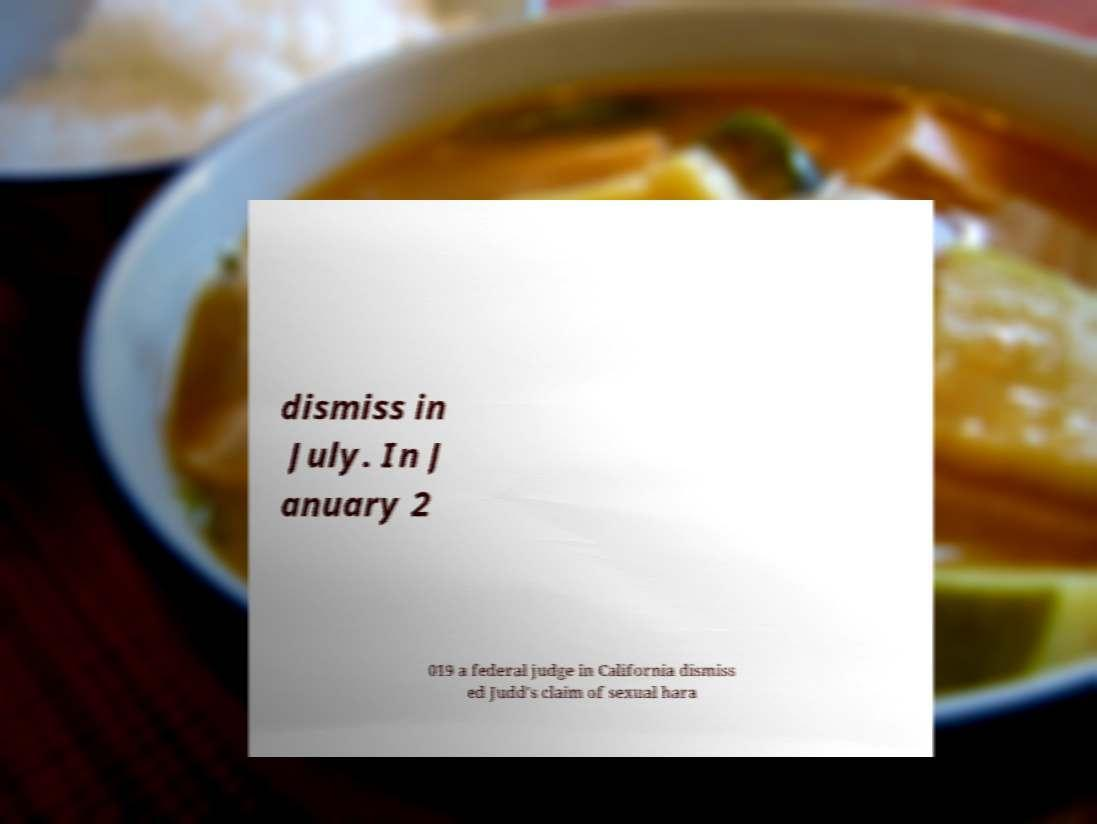Please read and relay the text visible in this image. What does it say? dismiss in July. In J anuary 2 019 a federal judge in California dismiss ed Judd's claim of sexual hara 